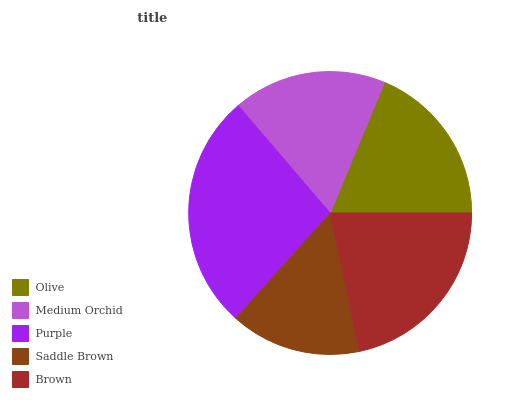Is Saddle Brown the minimum?
Answer yes or no. Yes. Is Purple the maximum?
Answer yes or no. Yes. Is Medium Orchid the minimum?
Answer yes or no. No. Is Medium Orchid the maximum?
Answer yes or no. No. Is Olive greater than Medium Orchid?
Answer yes or no. Yes. Is Medium Orchid less than Olive?
Answer yes or no. Yes. Is Medium Orchid greater than Olive?
Answer yes or no. No. Is Olive less than Medium Orchid?
Answer yes or no. No. Is Olive the high median?
Answer yes or no. Yes. Is Olive the low median?
Answer yes or no. Yes. Is Saddle Brown the high median?
Answer yes or no. No. Is Medium Orchid the low median?
Answer yes or no. No. 